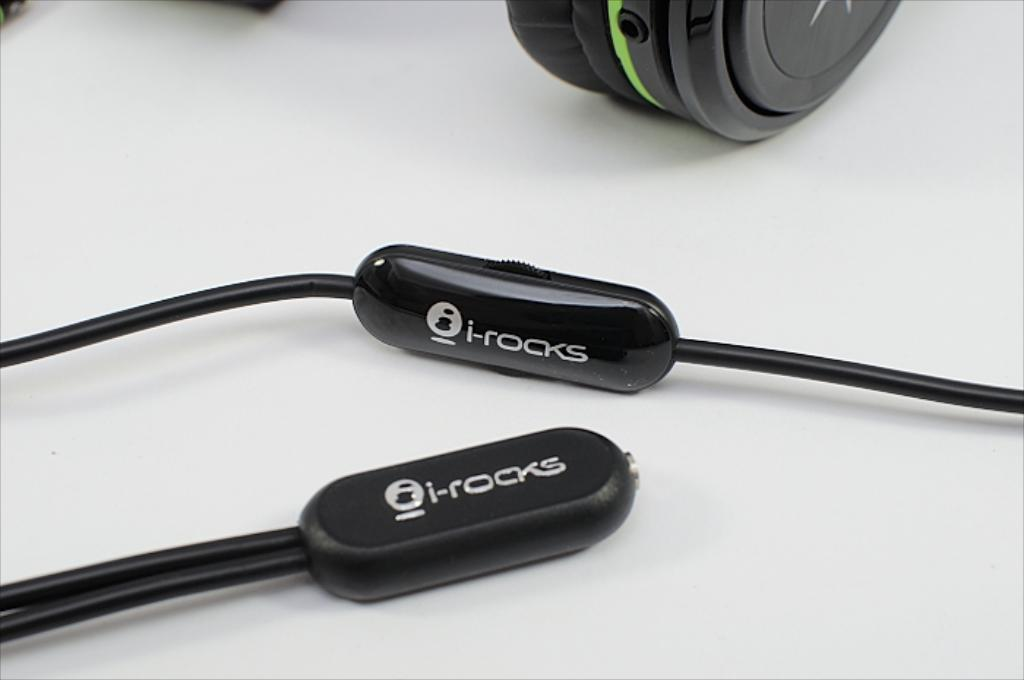<image>
Describe the image concisely. i-rocks headphones are displayed on their side so that the logo is seen. 